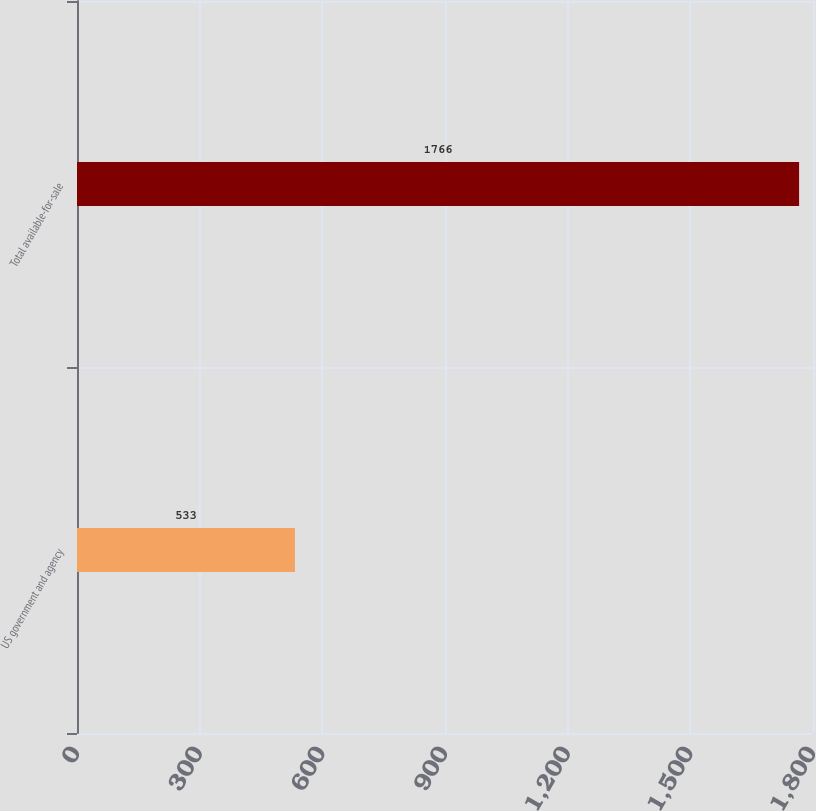<chart> <loc_0><loc_0><loc_500><loc_500><bar_chart><fcel>US government and agency<fcel>Total available-for-sale<nl><fcel>533<fcel>1766<nl></chart> 